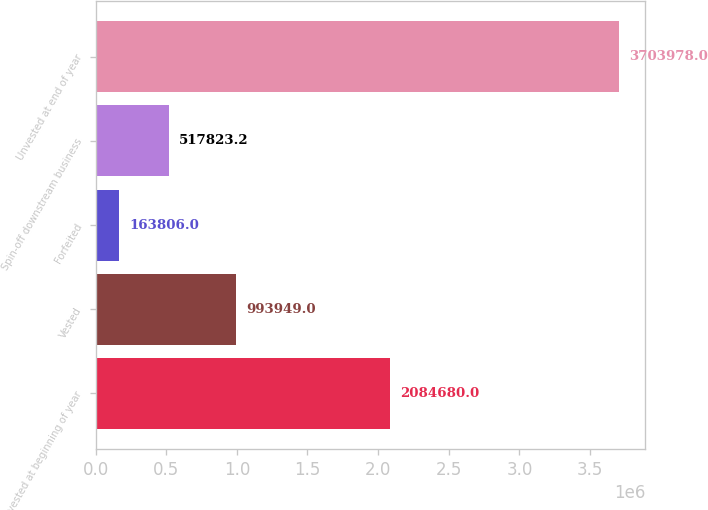<chart> <loc_0><loc_0><loc_500><loc_500><bar_chart><fcel>Unvested at beginning of year<fcel>Vested<fcel>Forfeited<fcel>Spin-off downstream business<fcel>Unvested at end of year<nl><fcel>2.08468e+06<fcel>993949<fcel>163806<fcel>517823<fcel>3.70398e+06<nl></chart> 